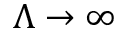<formula> <loc_0><loc_0><loc_500><loc_500>\Lambda \to \infty</formula> 